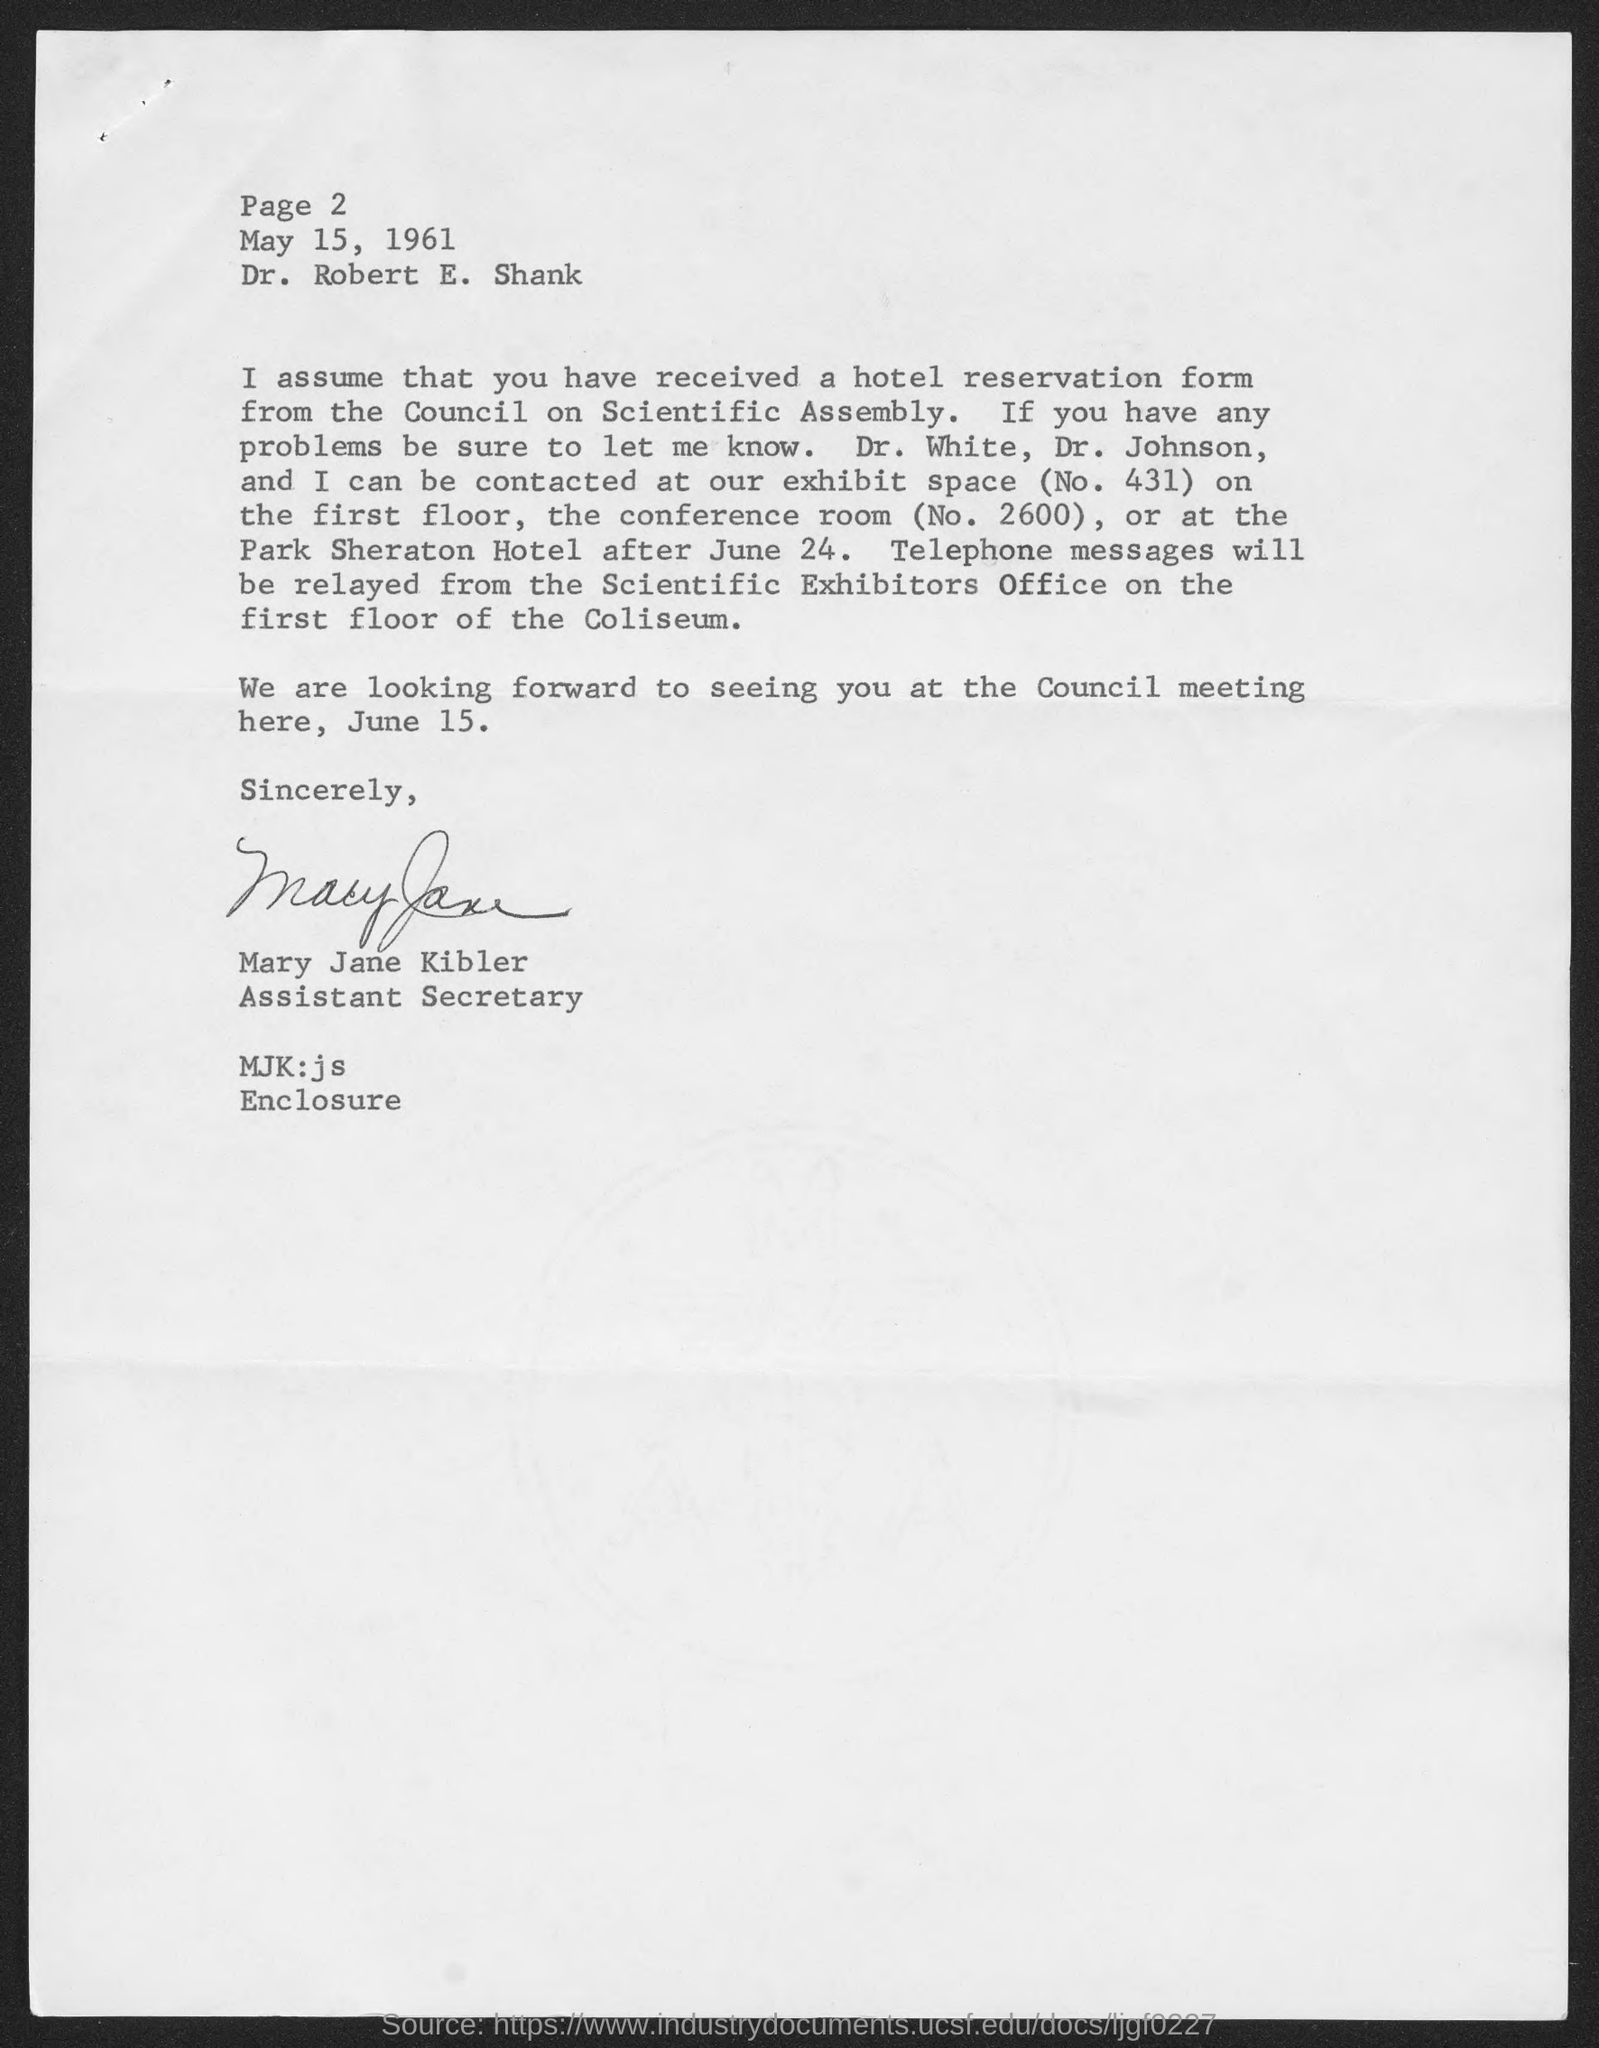Identify some key points in this picture. The date mentioned in this letter is May 15, 1961. Mary Jane Kibler holds the designation of Assistant Secretary. The letter is addressed to Dr. Robert E. Shank. 